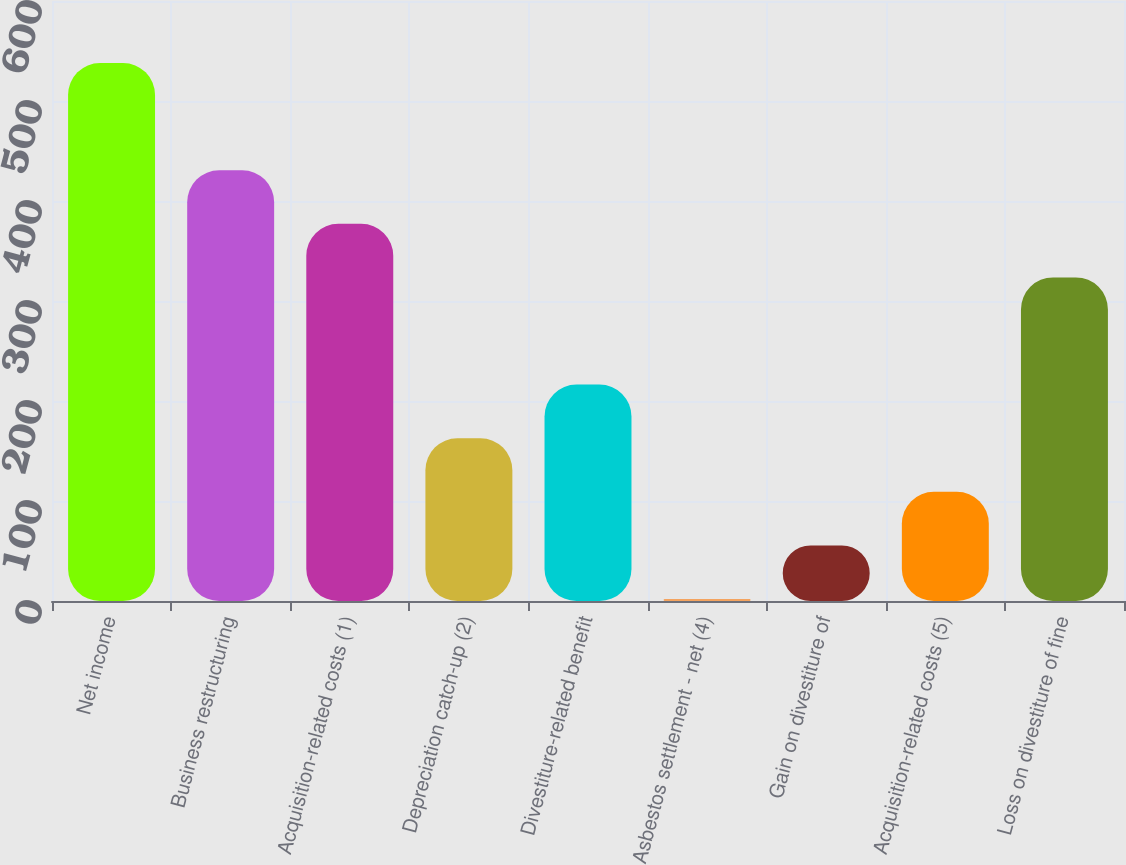<chart> <loc_0><loc_0><loc_500><loc_500><bar_chart><fcel>Net income<fcel>Business restructuring<fcel>Acquisition-related costs (1)<fcel>Depreciation catch-up (2)<fcel>Divestiture-related benefit<fcel>Asbestos settlement - net (4)<fcel>Gain on divestiture of<fcel>Acquisition-related costs (5)<fcel>Loss on divestiture of fine<nl><fcel>538<fcel>430.8<fcel>377.2<fcel>162.8<fcel>216.4<fcel>2<fcel>55.6<fcel>109.2<fcel>323.6<nl></chart> 